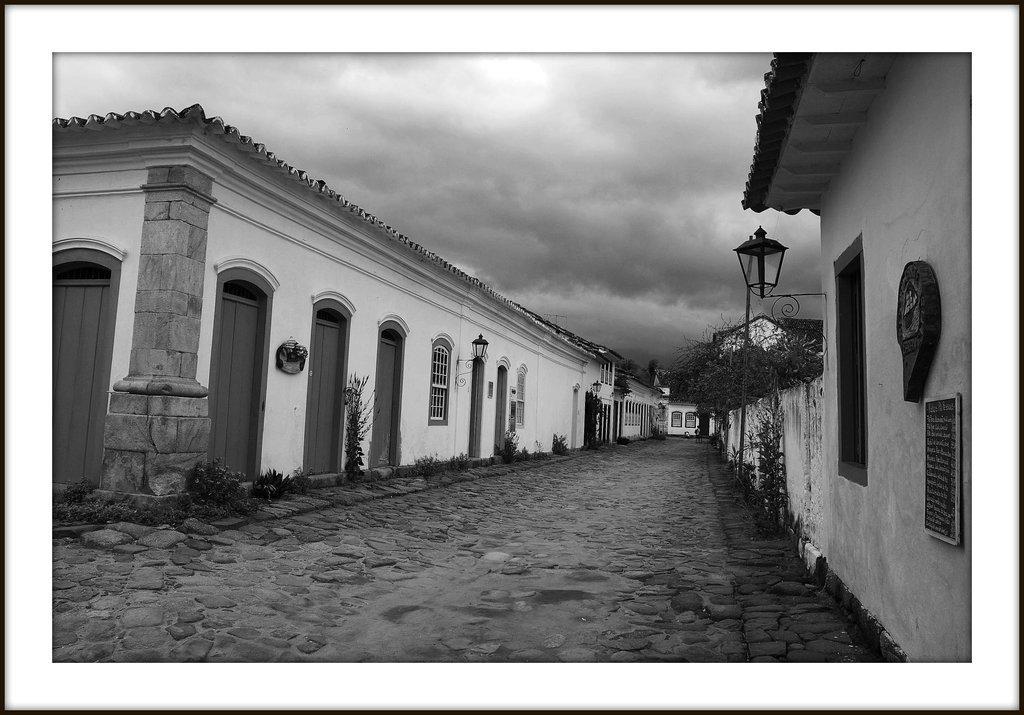In one or two sentences, can you explain what this image depicts? In the picture I can see buildings, lights on walls, plants and some other objects on the ground. In the background I can see the sky. This picture is black and white in color. 